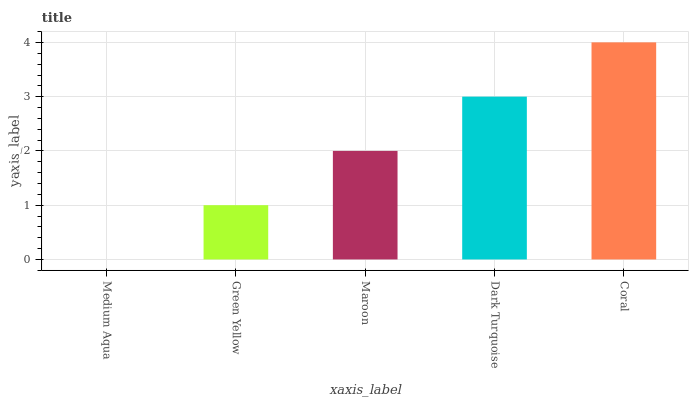Is Medium Aqua the minimum?
Answer yes or no. Yes. Is Coral the maximum?
Answer yes or no. Yes. Is Green Yellow the minimum?
Answer yes or no. No. Is Green Yellow the maximum?
Answer yes or no. No. Is Green Yellow greater than Medium Aqua?
Answer yes or no. Yes. Is Medium Aqua less than Green Yellow?
Answer yes or no. Yes. Is Medium Aqua greater than Green Yellow?
Answer yes or no. No. Is Green Yellow less than Medium Aqua?
Answer yes or no. No. Is Maroon the high median?
Answer yes or no. Yes. Is Maroon the low median?
Answer yes or no. Yes. Is Coral the high median?
Answer yes or no. No. Is Green Yellow the low median?
Answer yes or no. No. 